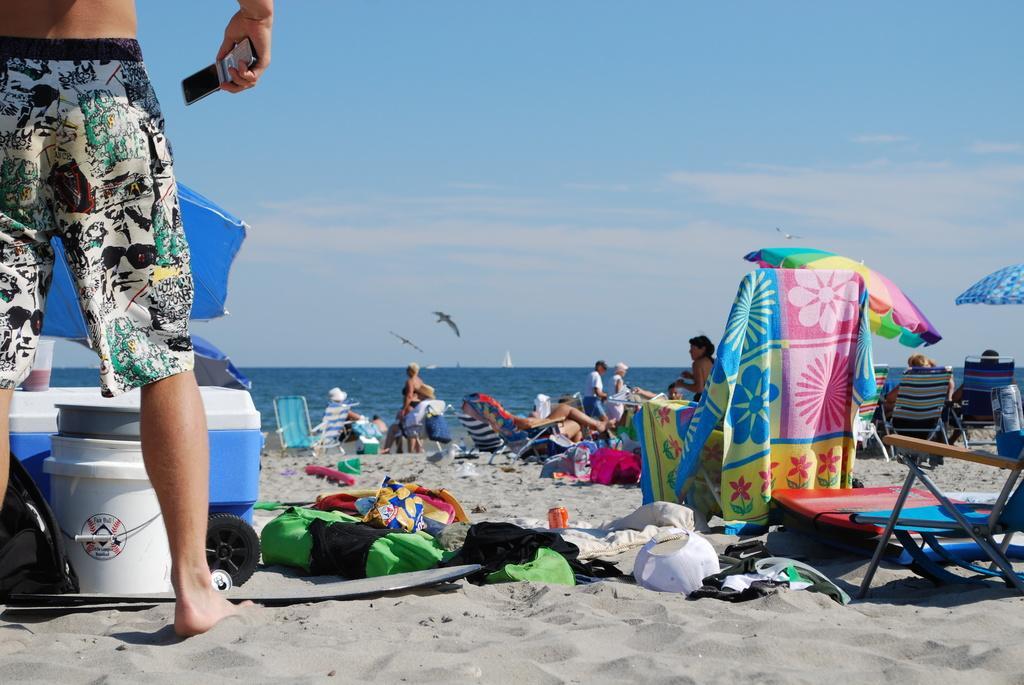Can you describe this image briefly? In the image we can see there are people around and there are even chairs. We can even see the bucket and the container. On the left side there is a person standing, wearing shorts and holding device in hand. Here we can see the umbrellas, water, sand and the sky. We can see there are even birds flying. 